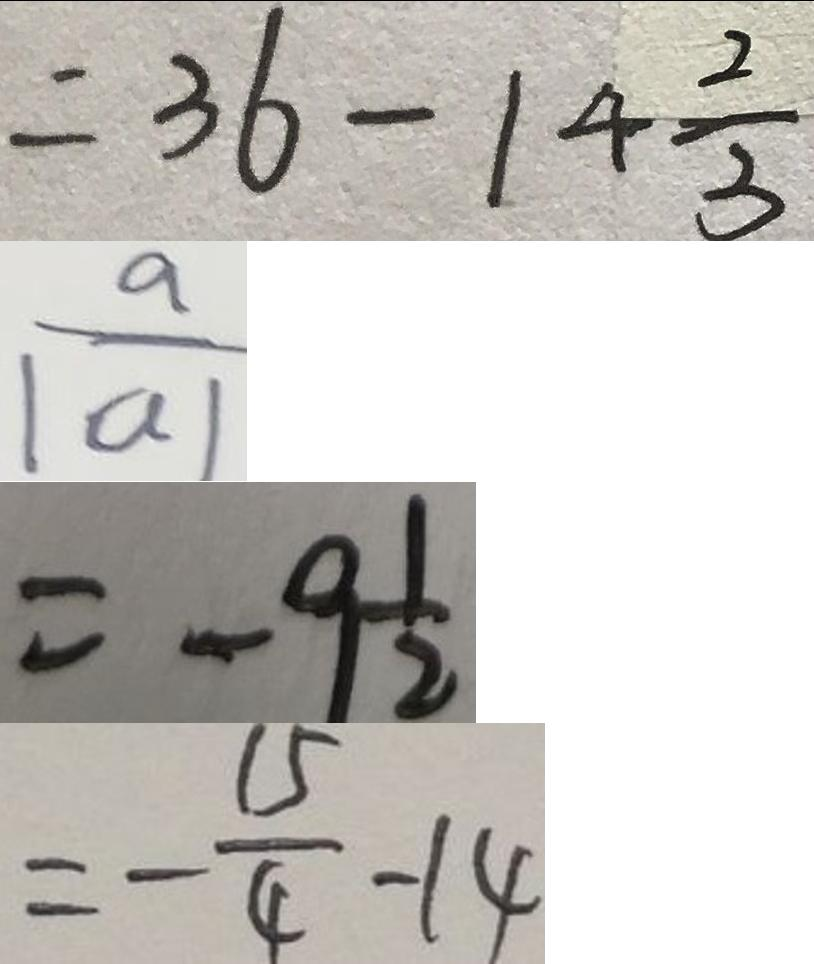Convert formula to latex. <formula><loc_0><loc_0><loc_500><loc_500>= 3 6 - 1 4 \frac { 2 } { 3 } 
 \frac { a } { \vert a \vert } 
 = - 9 \frac { 1 } { 2 } 
 = - \frac { 1 5 } { 4 } - 1 4</formula> 